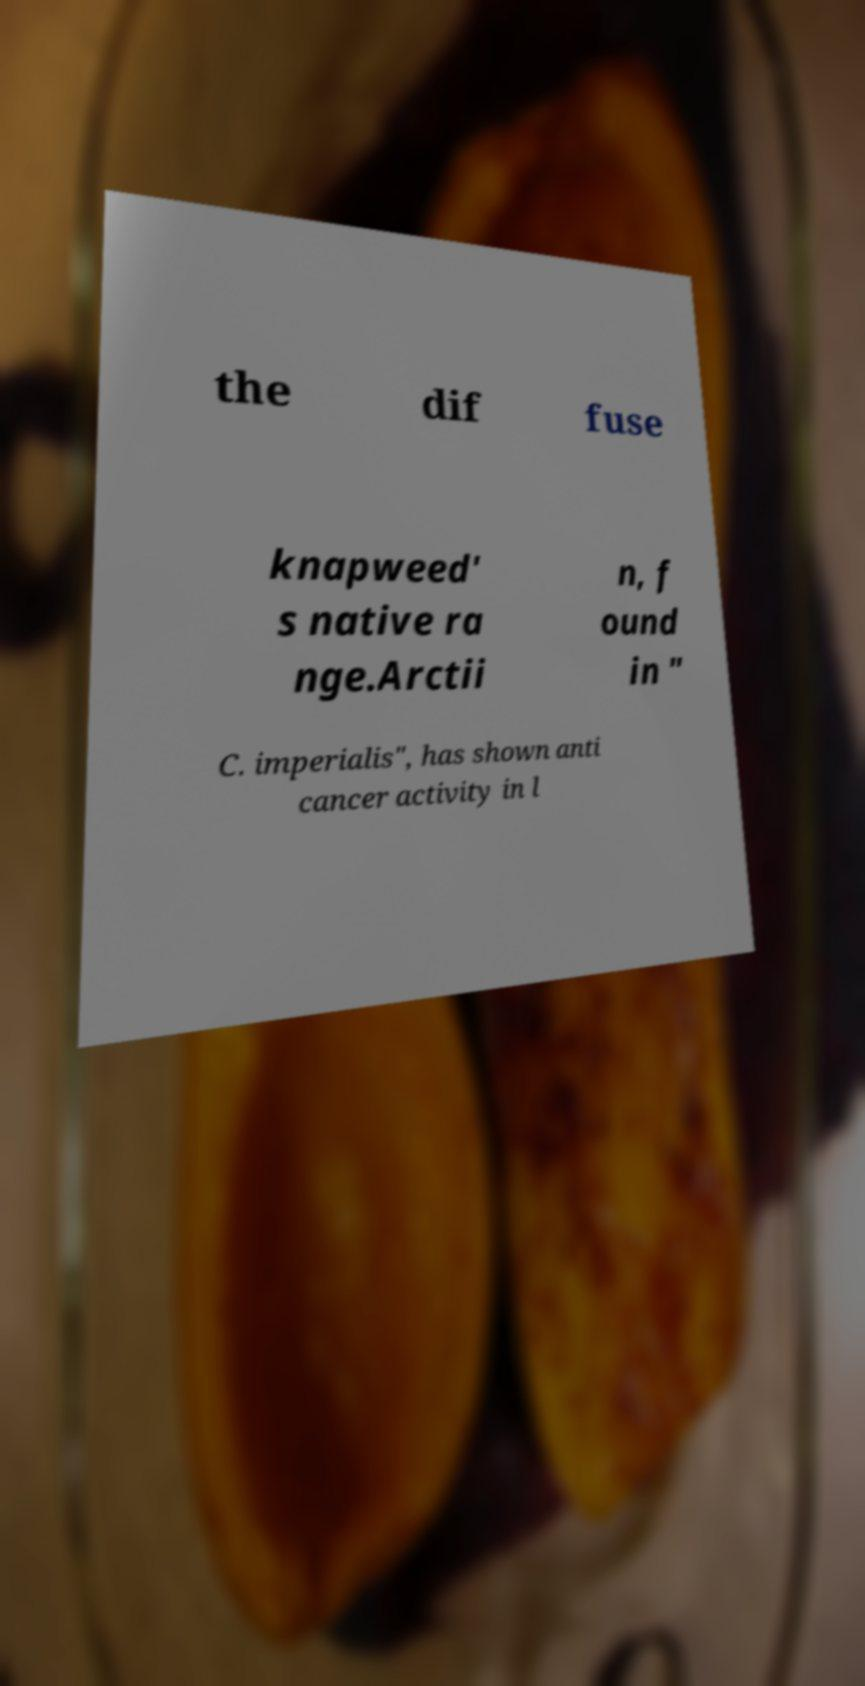Can you accurately transcribe the text from the provided image for me? the dif fuse knapweed' s native ra nge.Arctii n, f ound in " C. imperialis", has shown anti cancer activity in l 